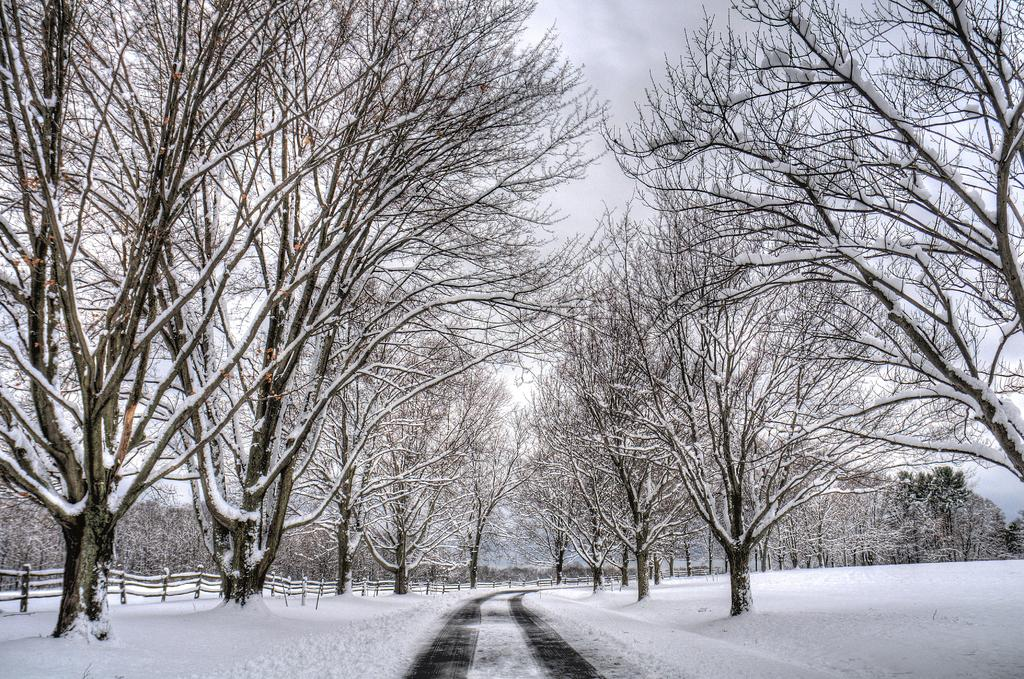What type of vegetation can be seen in the image? There are trees in the image. What is covering the ground in the image? There is snow at the bottom of the image. Where is the fencing located in the image? The fencing is on the left side of the image. What is visible at the top of the image? The sky is visible at the top of the image. What time of day is it in the image, as indicated by the hour on a clock? There is no clock present in the image, so we cannot determine the time of day based on an hour. Can you see a wren perched on any of the trees in the image? There is no wren visible in the image; only trees are present. 